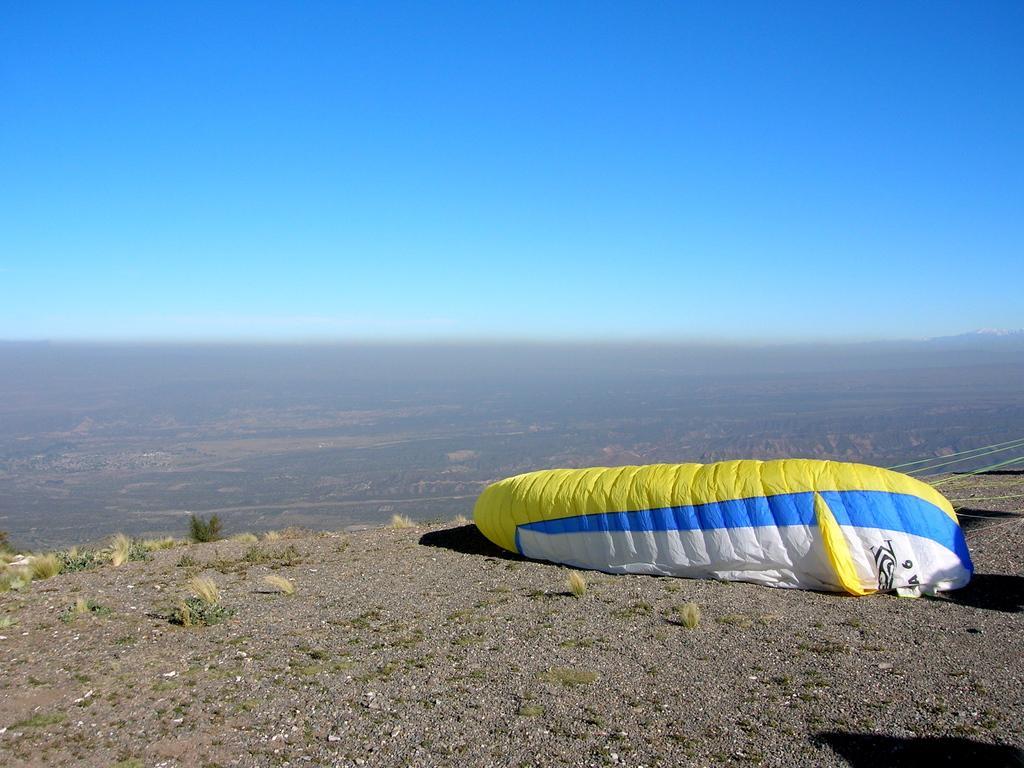Could you give a brief overview of what you see in this image? This image is taken from the top of a mountain where we can see a parachute on the ground. In the background, we can see the greenery and on the top the sky is in blue. 